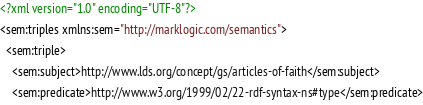<code> <loc_0><loc_0><loc_500><loc_500><_XML_><?xml version="1.0" encoding="UTF-8"?>
<sem:triples xmlns:sem="http://marklogic.com/semantics">
  <sem:triple>
    <sem:subject>http://www.lds.org/concept/gs/articles-of-faith</sem:subject>
    <sem:predicate>http://www.w3.org/1999/02/22-rdf-syntax-ns#type</sem:predicate></code> 